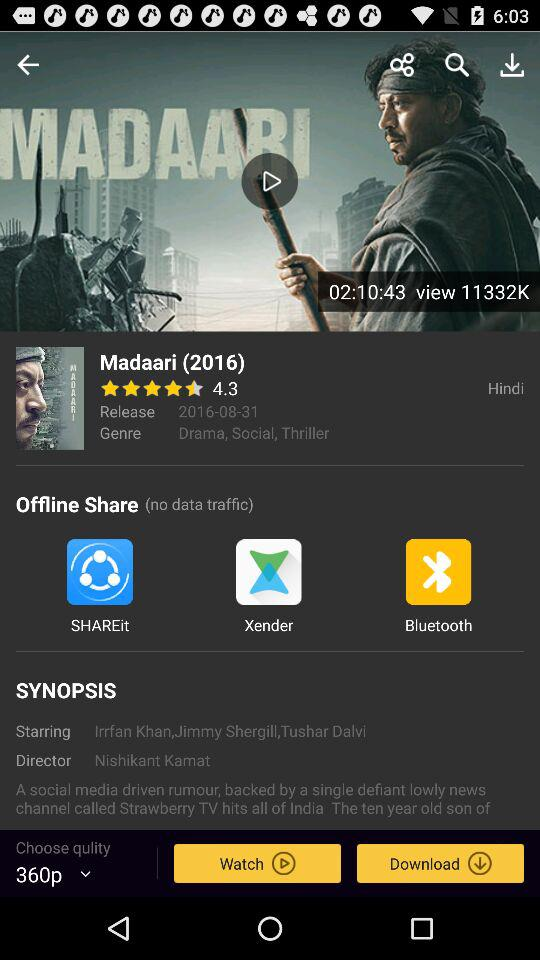What is the language of "Madaari"? The language is Hindi. 